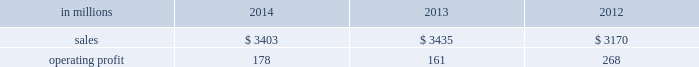Russia and europe .
Average sales price realizations for uncoated freesheet paper decreased in both europe and russia , reflecting weak economic conditions and soft market demand .
In russia , sales prices in rubles increased , but this improvement is masked by the impact of the currency depreciation against the u.s .
Dollar .
Input costs were significantly higher for wood in both europe and russia , partially offset by lower chemical costs .
Planned maintenance downtime costs were $ 11 million lower in 2014 than in 2013 .
Manufacturing and other operating costs were favorable .
Entering 2015 , sales volumes in the first quarter are expected to be seasonally weaker in russia , and about flat in europe .
Average sales price realizations for uncoated freesheet paper are expected to remain steady in europe , but increase in russia .
Input costs should be lower for oil and wood , partially offset by higher chemicals costs .
Indian papers net sales were $ 178 million in 2014 , $ 185 million ( $ 174 million excluding excise duties which were included in net sales in 2013 and prior periods ) in 2013 and $ 185 million ( $ 178 million excluding excise duties ) in 2012 .
Operating profits were $ 8 million ( a loss of $ 12 million excluding a gain related to the resolution of a legal contingency ) in 2014 , a loss of $ 145 million ( a loss of $ 22 million excluding goodwill and trade name impairment charges ) in 2013 and a loss of $ 16 million in 2012 .
Average sales price realizations improved in 2014 compared with 2013 due to the impact of price increases implemented in 2013 .
Sales volumes were flat , reflecting weak economic conditions .
Input costs were higher , primarily for wood .
Operating costs and planned maintenance downtime costs were lower in 2014 .
Looking ahead to the first quarter of 2015 , sales volumes are expected to be seasonally higher .
Average sales price realizations are expected to decrease due to competitive pressures .
Asian printing papers net sales were $ 59 million in 2014 , $ 90 million in 2013 and $ 85 million in 2012 .
Operating profits were $ 0 million in 2014 and $ 1 million in both 2013 and 2012 .
U.s .
Pulp net sales were $ 895 million in 2014 compared with $ 815 million in 2013 and $ 725 million in 2012 .
Operating profits were $ 57 million in 2014 compared with $ 2 million in 2013 and a loss of $ 59 million in 2012 .
Sales volumes in 2014 increased from 2013 for both fluff pulp and market pulp reflecting improved market demand .
Average sales price realizations increased significantly for fluff pulp , while prices for market pulp were also higher .
Input costs for wood and energy were higher .
Operating costs were lower , but planned maintenance downtime costs were $ 1 million higher .
Compared with the fourth quarter of 2014 , sales volumes in the first quarter of 2015 , are expected to decrease for market pulp , but be slightly higher for fluff pulp .
Average sales price realizations are expected to to be stable for fluff pulp and softwood market pulp , while hardwood market pulp prices are expected to improve .
Input costs should be flat .
Planned maintenance downtime costs should be about $ 13 million higher than in the fourth quarter of 2014 .
Consumer packaging demand and pricing for consumer packaging products correlate closely with consumer spending and general economic activity .
In addition to prices and volumes , major factors affecting the profitability of consumer packaging are raw material and energy costs , freight costs , manufacturing efficiency and product mix .
Consumer packaging net sales in 2014 decreased 1% ( 1 % ) from 2013 , but increased 7% ( 7 % ) from 2012 .
Operating profits increased 11% ( 11 % ) from 2013 , but decreased 34% ( 34 % ) from 2012 .
Excluding sheet plant closure costs , costs associated with the permanent shutdown of a paper machine at our augusta , georgia mill and costs related to the sale of the shorewood business , 2014 operating profits were 11% ( 11 % ) lower than in 2013 , and 30% ( 30 % ) lower than in 2012 .
Benefits from higher average sales price realizations and a favorable mix ( $ 60 million ) were offset by lower sales volumes ( $ 11 million ) , higher operating costs ( $ 9 million ) , higher planned maintenance downtime costs ( $ 12 million ) , higher input costs ( $ 43 million ) and higher other costs ( $ 7 million ) .
In addition , operating profits in 2014 include $ 8 million of costs associated with sheet plant closures , while operating profits in 2013 include costs of $ 45 million related to the permanent shutdown of a paper machine at our augusta , georgia mill and $ 2 million of costs associated with the sale of the shorewood business .
Consumer packaging .
North american consumer packaging net sales were $ 2.0 billion in 2014 compared with $ 2.0 billion in 2013 and $ 2.0 billion in 2012 .
Operating profits were $ 92 million ( $ 100 million excluding sheet plant closure costs ) in 2014 compared with $ 63 million ( $ 110 million excluding paper machine shutdown costs and costs related to the sale of the shorewood business ) in 2013 and $ 165 million ( $ 162 million excluding a gain associated with the sale of the shorewood business in 2012 ) .
Coated paperboard sales volumes in 2014 were lower than in 2013 reflecting weaker market demand .
The business took about 41000 tons of market-related downtime in 2014 compared with about 24000 tons in 2013 .
Average sales price realizations increased year- .
What percentage where north american consumer packaging net sales of consumer packaging sales in 2014? 
Computations: ((2 * 1000) / 3403)
Answer: 0.58772. Russia and europe .
Average sales price realizations for uncoated freesheet paper decreased in both europe and russia , reflecting weak economic conditions and soft market demand .
In russia , sales prices in rubles increased , but this improvement is masked by the impact of the currency depreciation against the u.s .
Dollar .
Input costs were significantly higher for wood in both europe and russia , partially offset by lower chemical costs .
Planned maintenance downtime costs were $ 11 million lower in 2014 than in 2013 .
Manufacturing and other operating costs were favorable .
Entering 2015 , sales volumes in the first quarter are expected to be seasonally weaker in russia , and about flat in europe .
Average sales price realizations for uncoated freesheet paper are expected to remain steady in europe , but increase in russia .
Input costs should be lower for oil and wood , partially offset by higher chemicals costs .
Indian papers net sales were $ 178 million in 2014 , $ 185 million ( $ 174 million excluding excise duties which were included in net sales in 2013 and prior periods ) in 2013 and $ 185 million ( $ 178 million excluding excise duties ) in 2012 .
Operating profits were $ 8 million ( a loss of $ 12 million excluding a gain related to the resolution of a legal contingency ) in 2014 , a loss of $ 145 million ( a loss of $ 22 million excluding goodwill and trade name impairment charges ) in 2013 and a loss of $ 16 million in 2012 .
Average sales price realizations improved in 2014 compared with 2013 due to the impact of price increases implemented in 2013 .
Sales volumes were flat , reflecting weak economic conditions .
Input costs were higher , primarily for wood .
Operating costs and planned maintenance downtime costs were lower in 2014 .
Looking ahead to the first quarter of 2015 , sales volumes are expected to be seasonally higher .
Average sales price realizations are expected to decrease due to competitive pressures .
Asian printing papers net sales were $ 59 million in 2014 , $ 90 million in 2013 and $ 85 million in 2012 .
Operating profits were $ 0 million in 2014 and $ 1 million in both 2013 and 2012 .
U.s .
Pulp net sales were $ 895 million in 2014 compared with $ 815 million in 2013 and $ 725 million in 2012 .
Operating profits were $ 57 million in 2014 compared with $ 2 million in 2013 and a loss of $ 59 million in 2012 .
Sales volumes in 2014 increased from 2013 for both fluff pulp and market pulp reflecting improved market demand .
Average sales price realizations increased significantly for fluff pulp , while prices for market pulp were also higher .
Input costs for wood and energy were higher .
Operating costs were lower , but planned maintenance downtime costs were $ 1 million higher .
Compared with the fourth quarter of 2014 , sales volumes in the first quarter of 2015 , are expected to decrease for market pulp , but be slightly higher for fluff pulp .
Average sales price realizations are expected to to be stable for fluff pulp and softwood market pulp , while hardwood market pulp prices are expected to improve .
Input costs should be flat .
Planned maintenance downtime costs should be about $ 13 million higher than in the fourth quarter of 2014 .
Consumer packaging demand and pricing for consumer packaging products correlate closely with consumer spending and general economic activity .
In addition to prices and volumes , major factors affecting the profitability of consumer packaging are raw material and energy costs , freight costs , manufacturing efficiency and product mix .
Consumer packaging net sales in 2014 decreased 1% ( 1 % ) from 2013 , but increased 7% ( 7 % ) from 2012 .
Operating profits increased 11% ( 11 % ) from 2013 , but decreased 34% ( 34 % ) from 2012 .
Excluding sheet plant closure costs , costs associated with the permanent shutdown of a paper machine at our augusta , georgia mill and costs related to the sale of the shorewood business , 2014 operating profits were 11% ( 11 % ) lower than in 2013 , and 30% ( 30 % ) lower than in 2012 .
Benefits from higher average sales price realizations and a favorable mix ( $ 60 million ) were offset by lower sales volumes ( $ 11 million ) , higher operating costs ( $ 9 million ) , higher planned maintenance downtime costs ( $ 12 million ) , higher input costs ( $ 43 million ) and higher other costs ( $ 7 million ) .
In addition , operating profits in 2014 include $ 8 million of costs associated with sheet plant closures , while operating profits in 2013 include costs of $ 45 million related to the permanent shutdown of a paper machine at our augusta , georgia mill and $ 2 million of costs associated with the sale of the shorewood business .
Consumer packaging .
North american consumer packaging net sales were $ 2.0 billion in 2014 compared with $ 2.0 billion in 2013 and $ 2.0 billion in 2012 .
Operating profits were $ 92 million ( $ 100 million excluding sheet plant closure costs ) in 2014 compared with $ 63 million ( $ 110 million excluding paper machine shutdown costs and costs related to the sale of the shorewood business ) in 2013 and $ 165 million ( $ 162 million excluding a gain associated with the sale of the shorewood business in 2012 ) .
Coated paperboard sales volumes in 2014 were lower than in 2013 reflecting weaker market demand .
The business took about 41000 tons of market-related downtime in 2014 compared with about 24000 tons in 2013 .
Average sales price realizations increased year- .
What was the average net sales for north american consumer packaging from 2012? 
Computations: ((((2.0 + 2.0) + 2.0) + 3) / 2)
Answer: 4.5. 